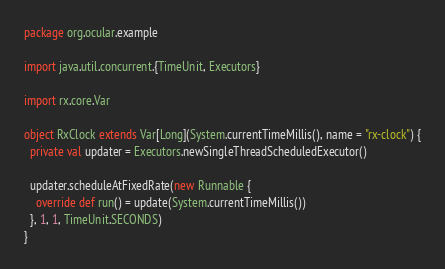<code> <loc_0><loc_0><loc_500><loc_500><_Scala_>package org.ocular.example

import java.util.concurrent.{TimeUnit, Executors}

import rx.core.Var

object RxClock extends Var[Long](System.currentTimeMillis(), name = "rx-clock") {
  private val updater = Executors.newSingleThreadScheduledExecutor()

  updater.scheduleAtFixedRate(new Runnable {
    override def run() = update(System.currentTimeMillis())
  }, 1, 1, TimeUnit.SECONDS)
}
</code> 